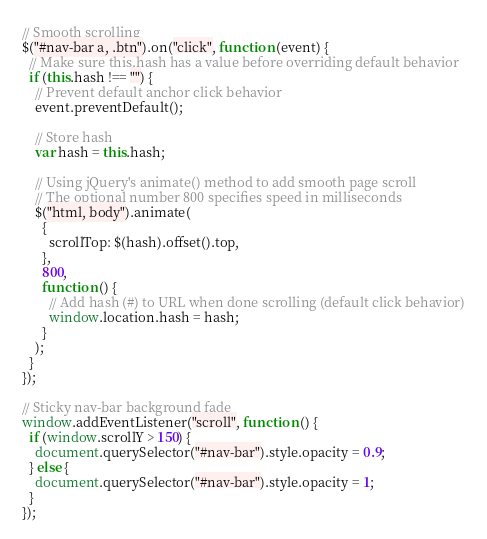<code> <loc_0><loc_0><loc_500><loc_500><_JavaScript_>// Smooth scrolling
$("#nav-bar a, .btn").on("click", function (event) {
  // Make sure this.hash has a value before overriding default behavior
  if (this.hash !== "") {
    // Prevent default anchor click behavior
    event.preventDefault();

    // Store hash
    var hash = this.hash;

    // Using jQuery's animate() method to add smooth page scroll
    // The optional number 800 specifies speed in milliseconds
    $("html, body").animate(
      {
        scrollTop: $(hash).offset().top,
      },
      800,
      function () {
        // Add hash (#) to URL when done scrolling (default click behavior)
        window.location.hash = hash;
      }
    );
  }
});

// Sticky nav-bar background fade
window.addEventListener("scroll", function () {
  if (window.scrollY > 150) {
    document.querySelector("#nav-bar").style.opacity = 0.9;
  } else {
    document.querySelector("#nav-bar").style.opacity = 1;
  }
});
</code> 